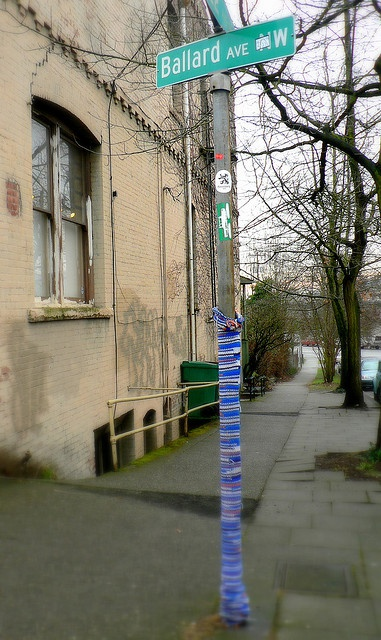Describe the objects in this image and their specific colors. I can see car in darkgray, lightblue, and black tones, car in darkgray, gray, maroon, and black tones, and car in darkgray, black, gray, and darkgreen tones in this image. 